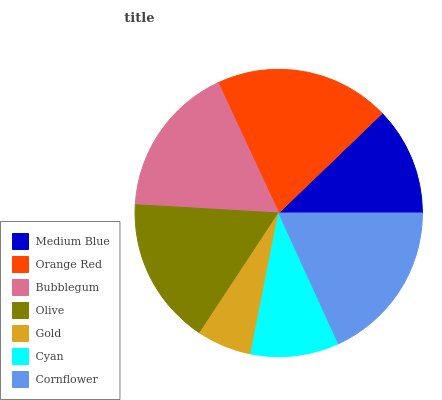Is Gold the minimum?
Answer yes or no. Yes. Is Orange Red the maximum?
Answer yes or no. Yes. Is Bubblegum the minimum?
Answer yes or no. No. Is Bubblegum the maximum?
Answer yes or no. No. Is Orange Red greater than Bubblegum?
Answer yes or no. Yes. Is Bubblegum less than Orange Red?
Answer yes or no. Yes. Is Bubblegum greater than Orange Red?
Answer yes or no. No. Is Orange Red less than Bubblegum?
Answer yes or no. No. Is Olive the high median?
Answer yes or no. Yes. Is Olive the low median?
Answer yes or no. Yes. Is Orange Red the high median?
Answer yes or no. No. Is Orange Red the low median?
Answer yes or no. No. 